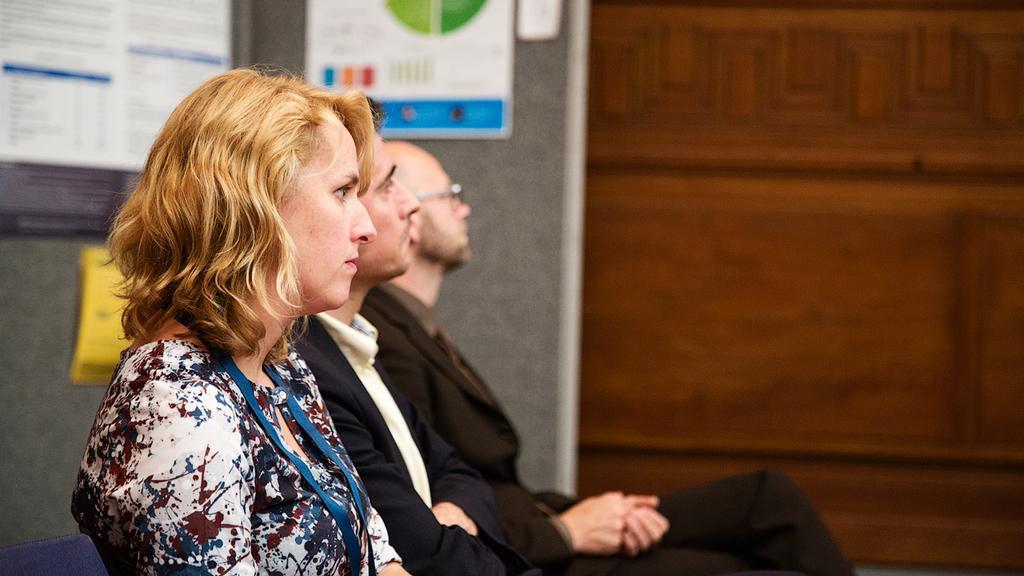In one or two sentences, can you explain what this image depicts? In this image I can see one woman and two men are sitting. I can see she is wearing colorful top and I can see those two are wearing black dress. In the background I can see few posters and on these posters I can see something is written. I can also see one of them is wearing specs. 